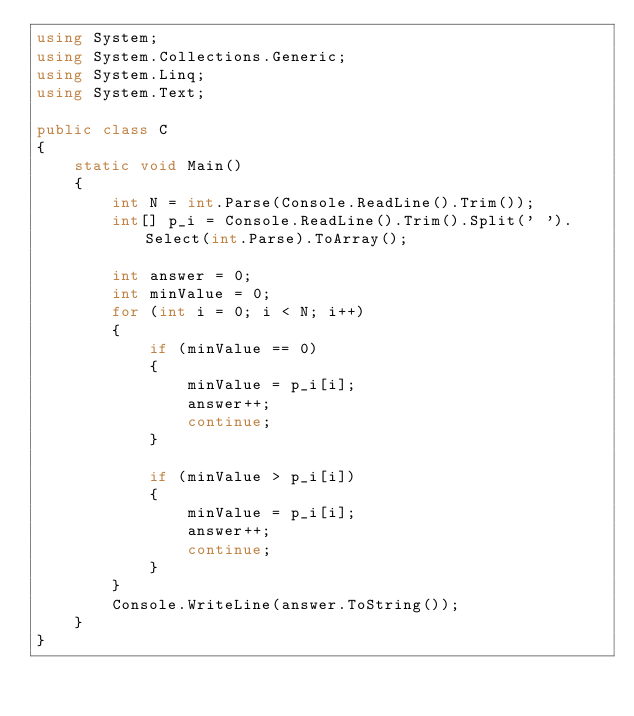<code> <loc_0><loc_0><loc_500><loc_500><_C#_>using System;
using System.Collections.Generic;
using System.Linq;
using System.Text;

public class C
{
    static void Main()
    {
        int N = int.Parse(Console.ReadLine().Trim());
        int[] p_i = Console.ReadLine().Trim().Split(' ').Select(int.Parse).ToArray();

        int answer = 0;
        int minValue = 0;
        for (int i = 0; i < N; i++)
        {
            if (minValue == 0)
            {
                minValue = p_i[i];
                answer++;
                continue;
            }

            if (minValue > p_i[i])
            {
                minValue = p_i[i];
                answer++;
                continue;
            }
        }
        Console.WriteLine(answer.ToString());
    }
}</code> 